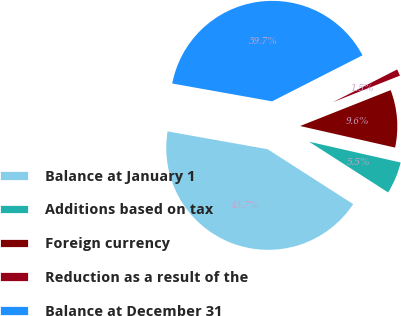<chart> <loc_0><loc_0><loc_500><loc_500><pie_chart><fcel>Balance at January 1<fcel>Additions based on tax<fcel>Foreign currency<fcel>Reduction as a result of the<fcel>Balance at December 31<nl><fcel>43.73%<fcel>5.52%<fcel>9.56%<fcel>1.49%<fcel>39.69%<nl></chart> 